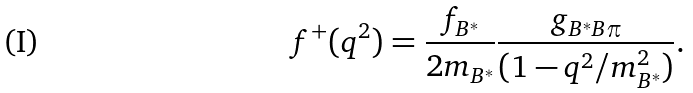Convert formula to latex. <formula><loc_0><loc_0><loc_500><loc_500>f ^ { + } ( q ^ { 2 } ) = \frac { f _ { B ^ { * } } } { 2 m _ { B ^ { * } } } \frac { g _ { B ^ { * } B \pi } } { ( 1 - q ^ { 2 } / m _ { B ^ { * } } ^ { 2 } ) } .</formula> 